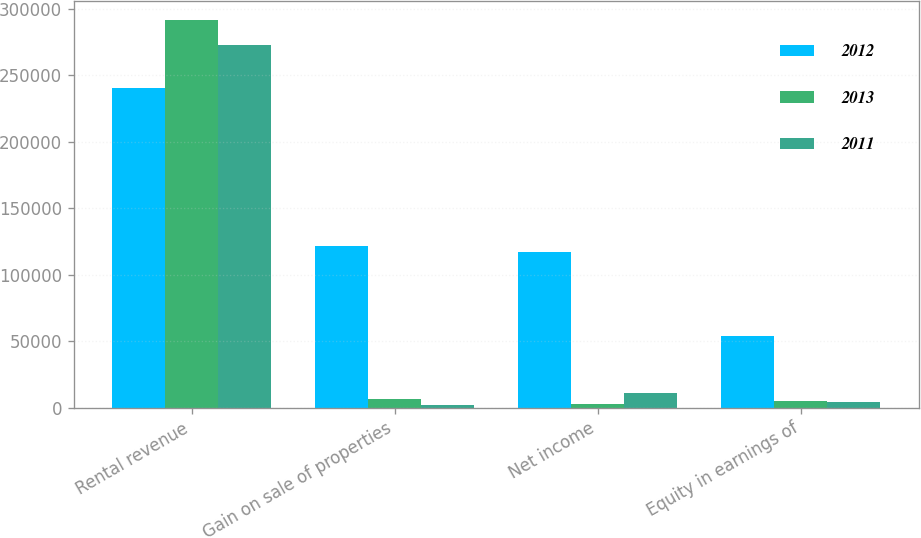<chart> <loc_0><loc_0><loc_500><loc_500><stacked_bar_chart><ecel><fcel>Rental revenue<fcel>Gain on sale of properties<fcel>Net income<fcel>Equity in earnings of<nl><fcel>2012<fcel>240064<fcel>121404<fcel>116832<fcel>54116<nl><fcel>2013<fcel>291534<fcel>6792<fcel>3125<fcel>4674<nl><fcel>2011<fcel>272937<fcel>2304<fcel>10709<fcel>4565<nl></chart> 